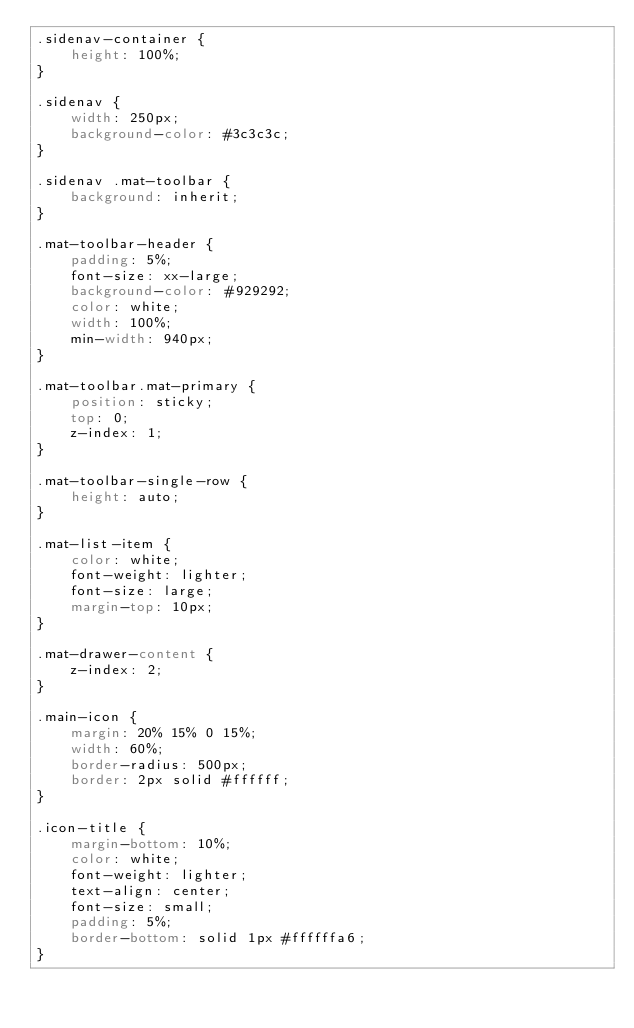<code> <loc_0><loc_0><loc_500><loc_500><_CSS_>.sidenav-container {
    height: 100%;
}

.sidenav {
    width: 250px;
    background-color: #3c3c3c;
}

.sidenav .mat-toolbar {
    background: inherit;
}

.mat-toolbar-header {
    padding: 5%;
    font-size: xx-large;
    background-color: #929292;
    color: white;
    width: 100%;
    min-width: 940px;
}

.mat-toolbar.mat-primary {
    position: sticky;
    top: 0;
    z-index: 1;
}

.mat-toolbar-single-row {
    height: auto;
}

.mat-list-item {
    color: white;
    font-weight: lighter;
    font-size: large;
    margin-top: 10px;
}

.mat-drawer-content {
    z-index: 2;
}

.main-icon {
    margin: 20% 15% 0 15%;
    width: 60%;
    border-radius: 500px;
    border: 2px solid #ffffff;
}

.icon-title {
    margin-bottom: 10%;
    color: white;
    font-weight: lighter;
    text-align: center;
    font-size: small;
    padding: 5%;
    border-bottom: solid 1px #ffffffa6;
}
</code> 